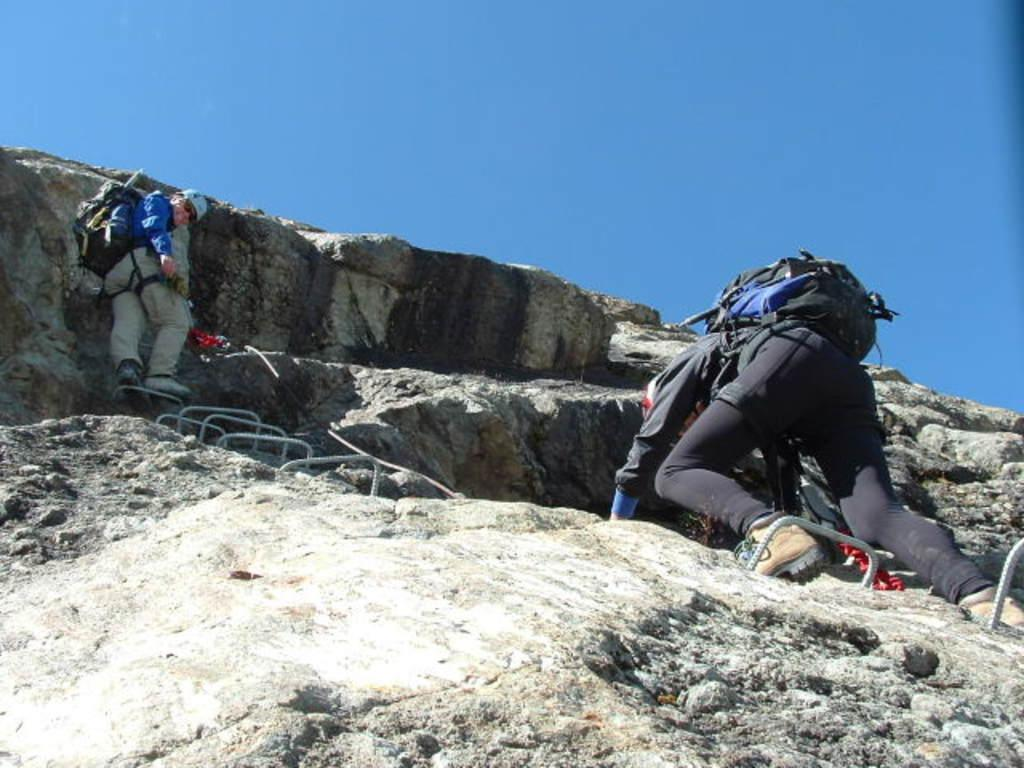How many people are in the image? There are people in the image, but the exact number is not specified. What are the people wearing on their bodies? The people are wearing bags and caps. What other objects can be seen in the image? There are rods and rocks in the image. What is visible at the top of the image? The sky is visible at the top of the image. What type of root can be seen growing from the rocks in the image? There is no root visible in the image, as it only features people, bags, caps, rods, rocks, and the sky. 